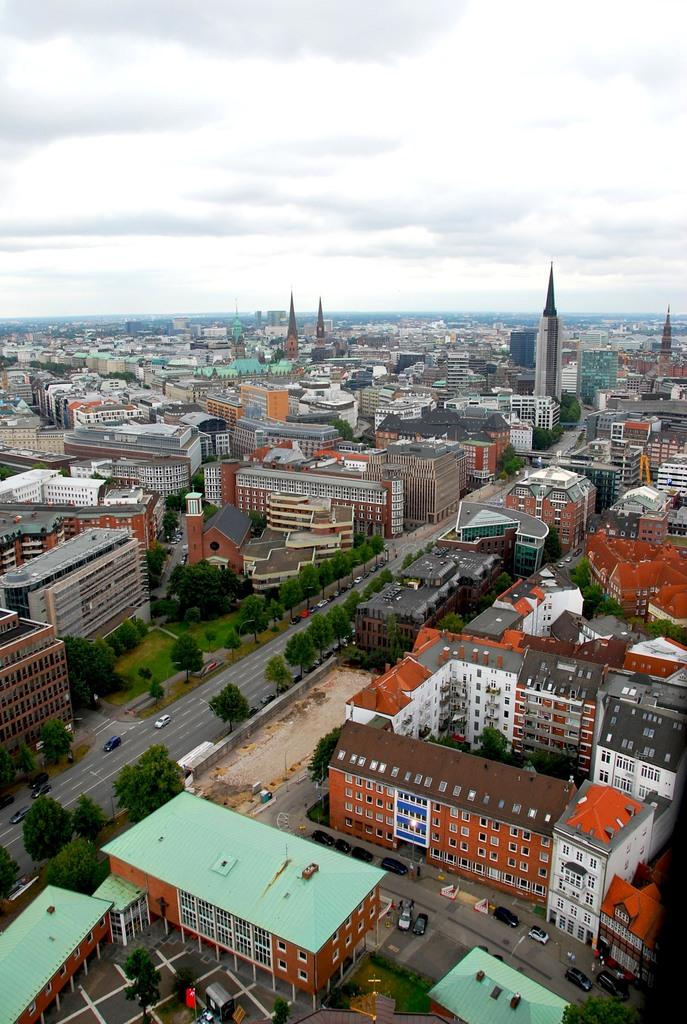What type of view is shown in the image? The image is an aerial view. What type of structures can be seen in the image? There are houses, towers, and buildings in the image. What type of vehicles are visible in the image? There are cars in the image. What type of transportation infrastructure is present in the image? There are roads in the image. What type of vegetation is present in the image? There are trees in the image. What part of the natural environment is visible in the image? The sky is visible in the image. How many guns are visible in the image? There are no guns present in the image. What type of bikes can be seen in the image? There are no bikes present in the image. 